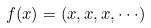Convert formula to latex. <formula><loc_0><loc_0><loc_500><loc_500>f ( x ) = ( x , x , x , \cdot \cdot \cdot )</formula> 